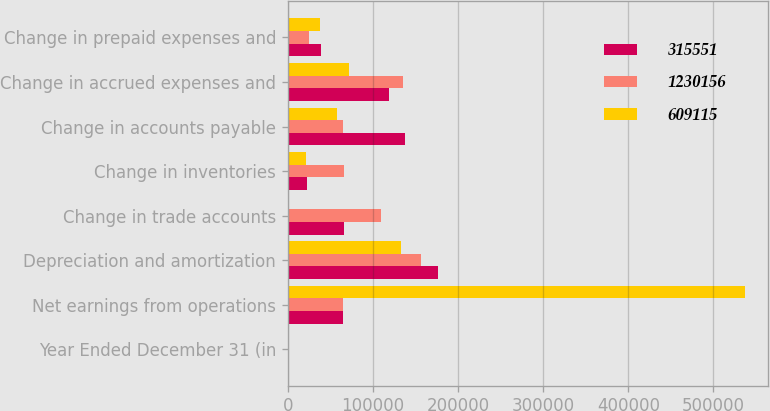Convert chart to OTSL. <chart><loc_0><loc_0><loc_500><loc_500><stacked_bar_chart><ecel><fcel>Year Ended December 31 (in<fcel>Net earnings from operations<fcel>Depreciation and amortization<fcel>Change in trade accounts<fcel>Change in inventories<fcel>Change in accounts payable<fcel>Change in accrued expenses and<fcel>Change in prepaid expenses and<nl><fcel>315551<fcel>2005<fcel>65421.5<fcel>176972<fcel>66611<fcel>22478<fcel>138144<fcel>118605<fcel>38631<nl><fcel>1.23016e+06<fcel>2004<fcel>65421.5<fcel>156128<fcel>110007<fcel>65528<fcel>65315<fcel>135616<fcel>25364<nl><fcel>609115<fcel>2003<fcel>536834<fcel>133436<fcel>1505<fcel>21061<fcel>58209<fcel>72097<fcel>38402<nl></chart> 